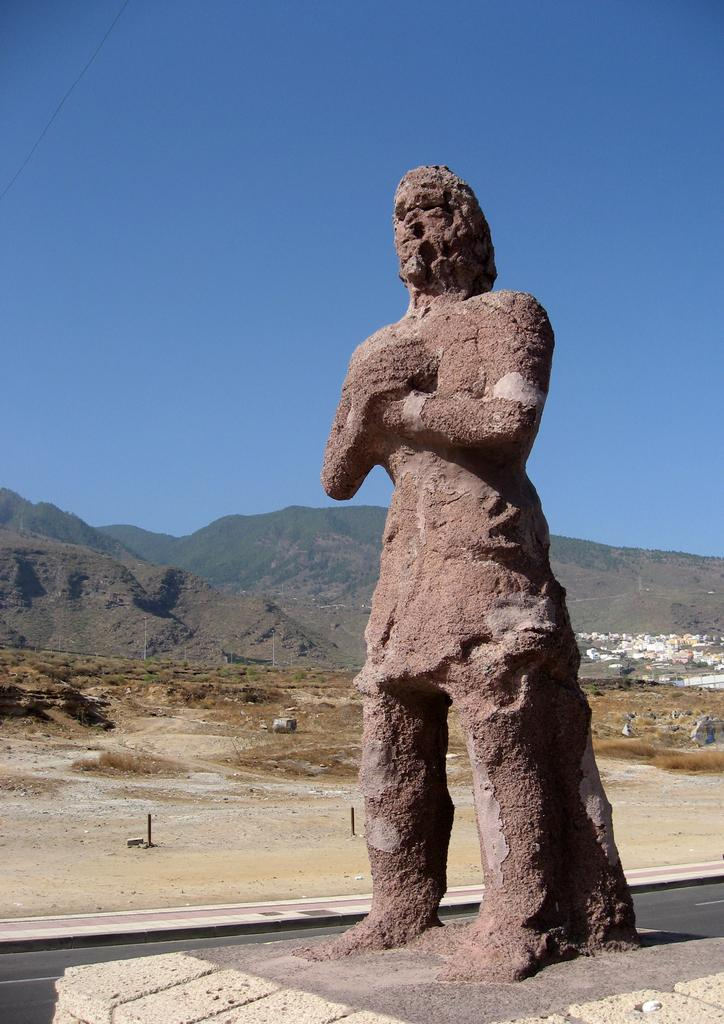What is the main subject in the image? There is a statue in the image. What else can be seen in the image besides the statue? There are poles, a group of houses, plants, hills, and a cloudy sky visible in the image. Can you describe the poles in the image? The poles are vertical structures that can be used for various purposes, such as supporting signs or wires. What type of vegetation is present in the image? The plants in the image are likely trees or bushes. What type of property can be seen in the image? There is no property mentioned or visible in the image; it features a statue, poles, houses, plants, hills, and a cloudy sky. What is the pan used for in the image? There is no pan present in the image. 